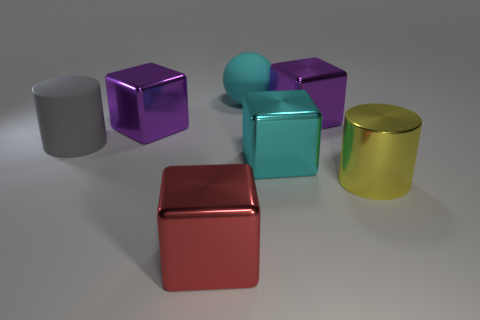How do the different shapes and colors of the objects interact with each other? The shapes and colors of the objects create a visually engaging contrast. The cubes and cylinder pairings offer a study in geometry, while the varying colors—purple, aqua, red, and yellow—provide a pleasing color palette that can draw the viewer's eye and evoke a sense of playfulness or a discussion on color theory. Do these objects have textures that would be interesting to touch? While the objects' surfaces appear smooth and might feel cool to the touch due to their shiny finishes, they may also provide a tactile experience reflective of their materials, such as the sleekness of polished metal or the slight resistance of a glossy coat. 